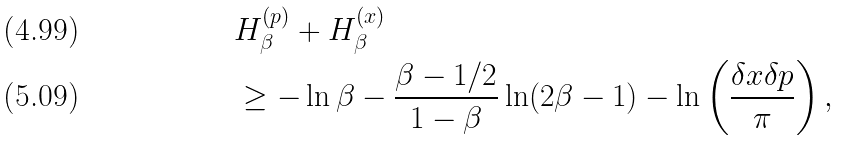Convert formula to latex. <formula><loc_0><loc_0><loc_500><loc_500>& H ^ { ( p ) } _ { \beta } + H ^ { ( x ) } _ { \beta } \\ & \geq - \ln \beta - \frac { \beta - 1 / 2 } { 1 - \beta } \ln ( 2 \beta - 1 ) - \ln \left ( \frac { \delta x \delta p } { \pi } \right ) ,</formula> 